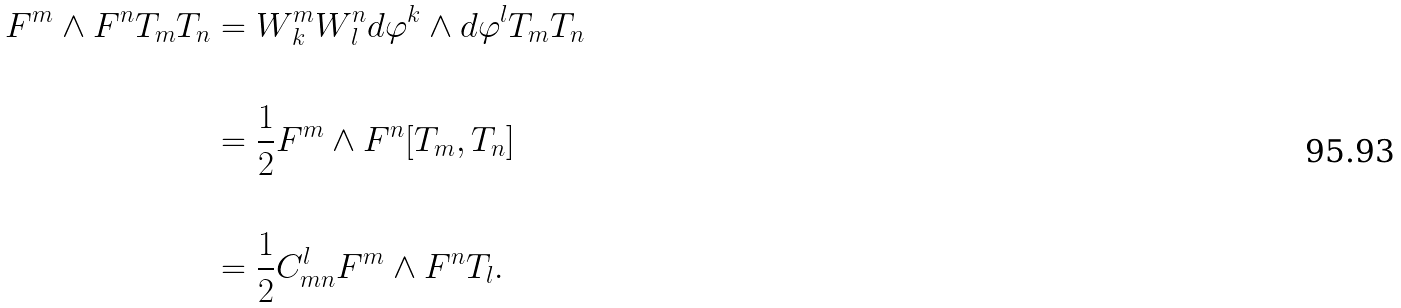<formula> <loc_0><loc_0><loc_500><loc_500>F ^ { m } \wedge F ^ { n } T _ { m } T _ { n } & = W ^ { m } _ { \, k } W ^ { n } _ { \, l } d \varphi ^ { k } \wedge d \varphi ^ { l } T _ { m } T _ { n } \\ \\ & = \frac { 1 } { 2 } F ^ { m } \wedge F ^ { n } [ T _ { m } , T _ { n } ] \\ \\ & = \frac { 1 } { 2 } C _ { m n } ^ { l } F ^ { m } \wedge F ^ { n } T _ { l } .</formula> 